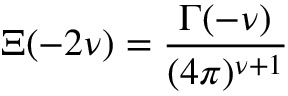Convert formula to latex. <formula><loc_0><loc_0><loc_500><loc_500>\Xi ( - 2 \nu ) = \frac { \Gamma ( - \nu ) } { ( 4 \pi ) ^ { \nu + 1 } } \,</formula> 